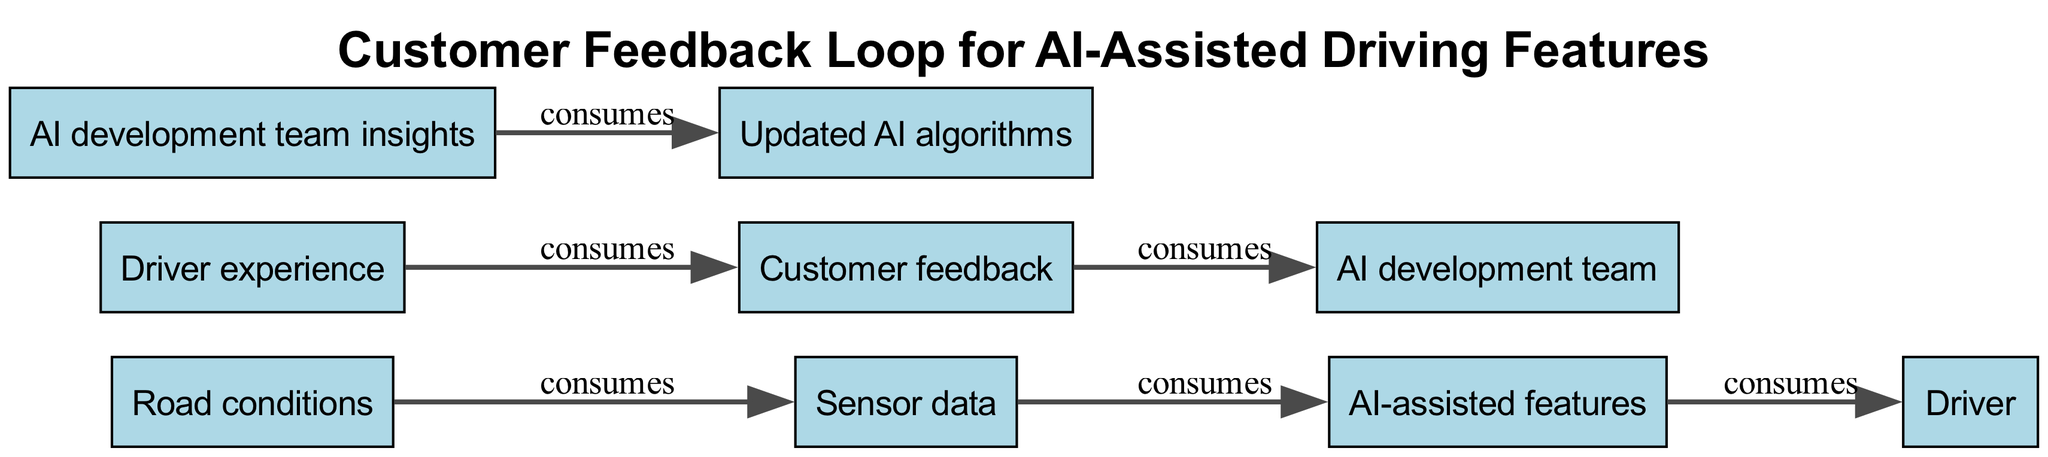What is the starting point of the feedback loop? The diagram indicates that the starting point of the feedback loop is "Driver," as they interact with AI-assisted features first.
Answer: Driver How many elements are present in the diagram? By counting each unique node listed in the diagram, we find there are six elements: Driver, AI-assisted features, Sensor data, Customer feedback, AI development team, Updated AI algorithms.
Answer: 6 What does the "AI-assisted features" consume? The diagram specifies that "AI-assisted features" consumes "Sensor data," establishing the relationship between these two elements.
Answer: Sensor data What is consumed by the "Customer feedback"? According to the diagram, "Customer feedback" consumes "Driver experience," which is crucial for assessing the driver's perspective.
Answer: Driver experience Which element consumes insights from the "AI development team"? The diagram shows that "Updated AI algorithms" consumes insights from the "AI development team," illustrating the flow of information necessary for AI advancements.
Answer: Updated AI algorithms How does "Driver" influence the feedback loop? The "Driver" influences the loop by consuming "AI-assisted features," which then leads to the collection of "Customer feedback," demonstrating the impact of driver interaction on AI development.
Answer: AI-assisted features What connects "Sensor data" to "AI-assisted features"? The connection between "Sensor data" and "AI-assisted features" is that "AI-assisted features" directly consume the data, indicating a dependency of the features on real-time inputs from the environment.
Answer: AI-assisted features How does customer feedback eventually affect AI algorithms? Customer feedback reaches the "AI development team," which utilizes it to provide insights that contribute to the creation of "Updated AI algorithms," completing the loop back to enhancements in driving features.
Answer: Updated AI algorithms 